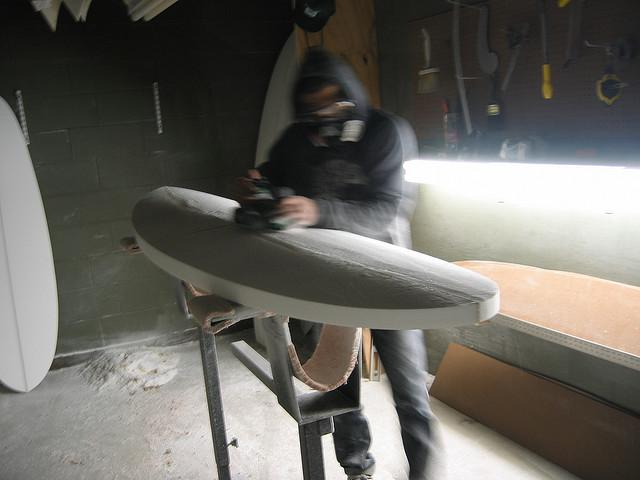What is the man wearing on his head? hood 